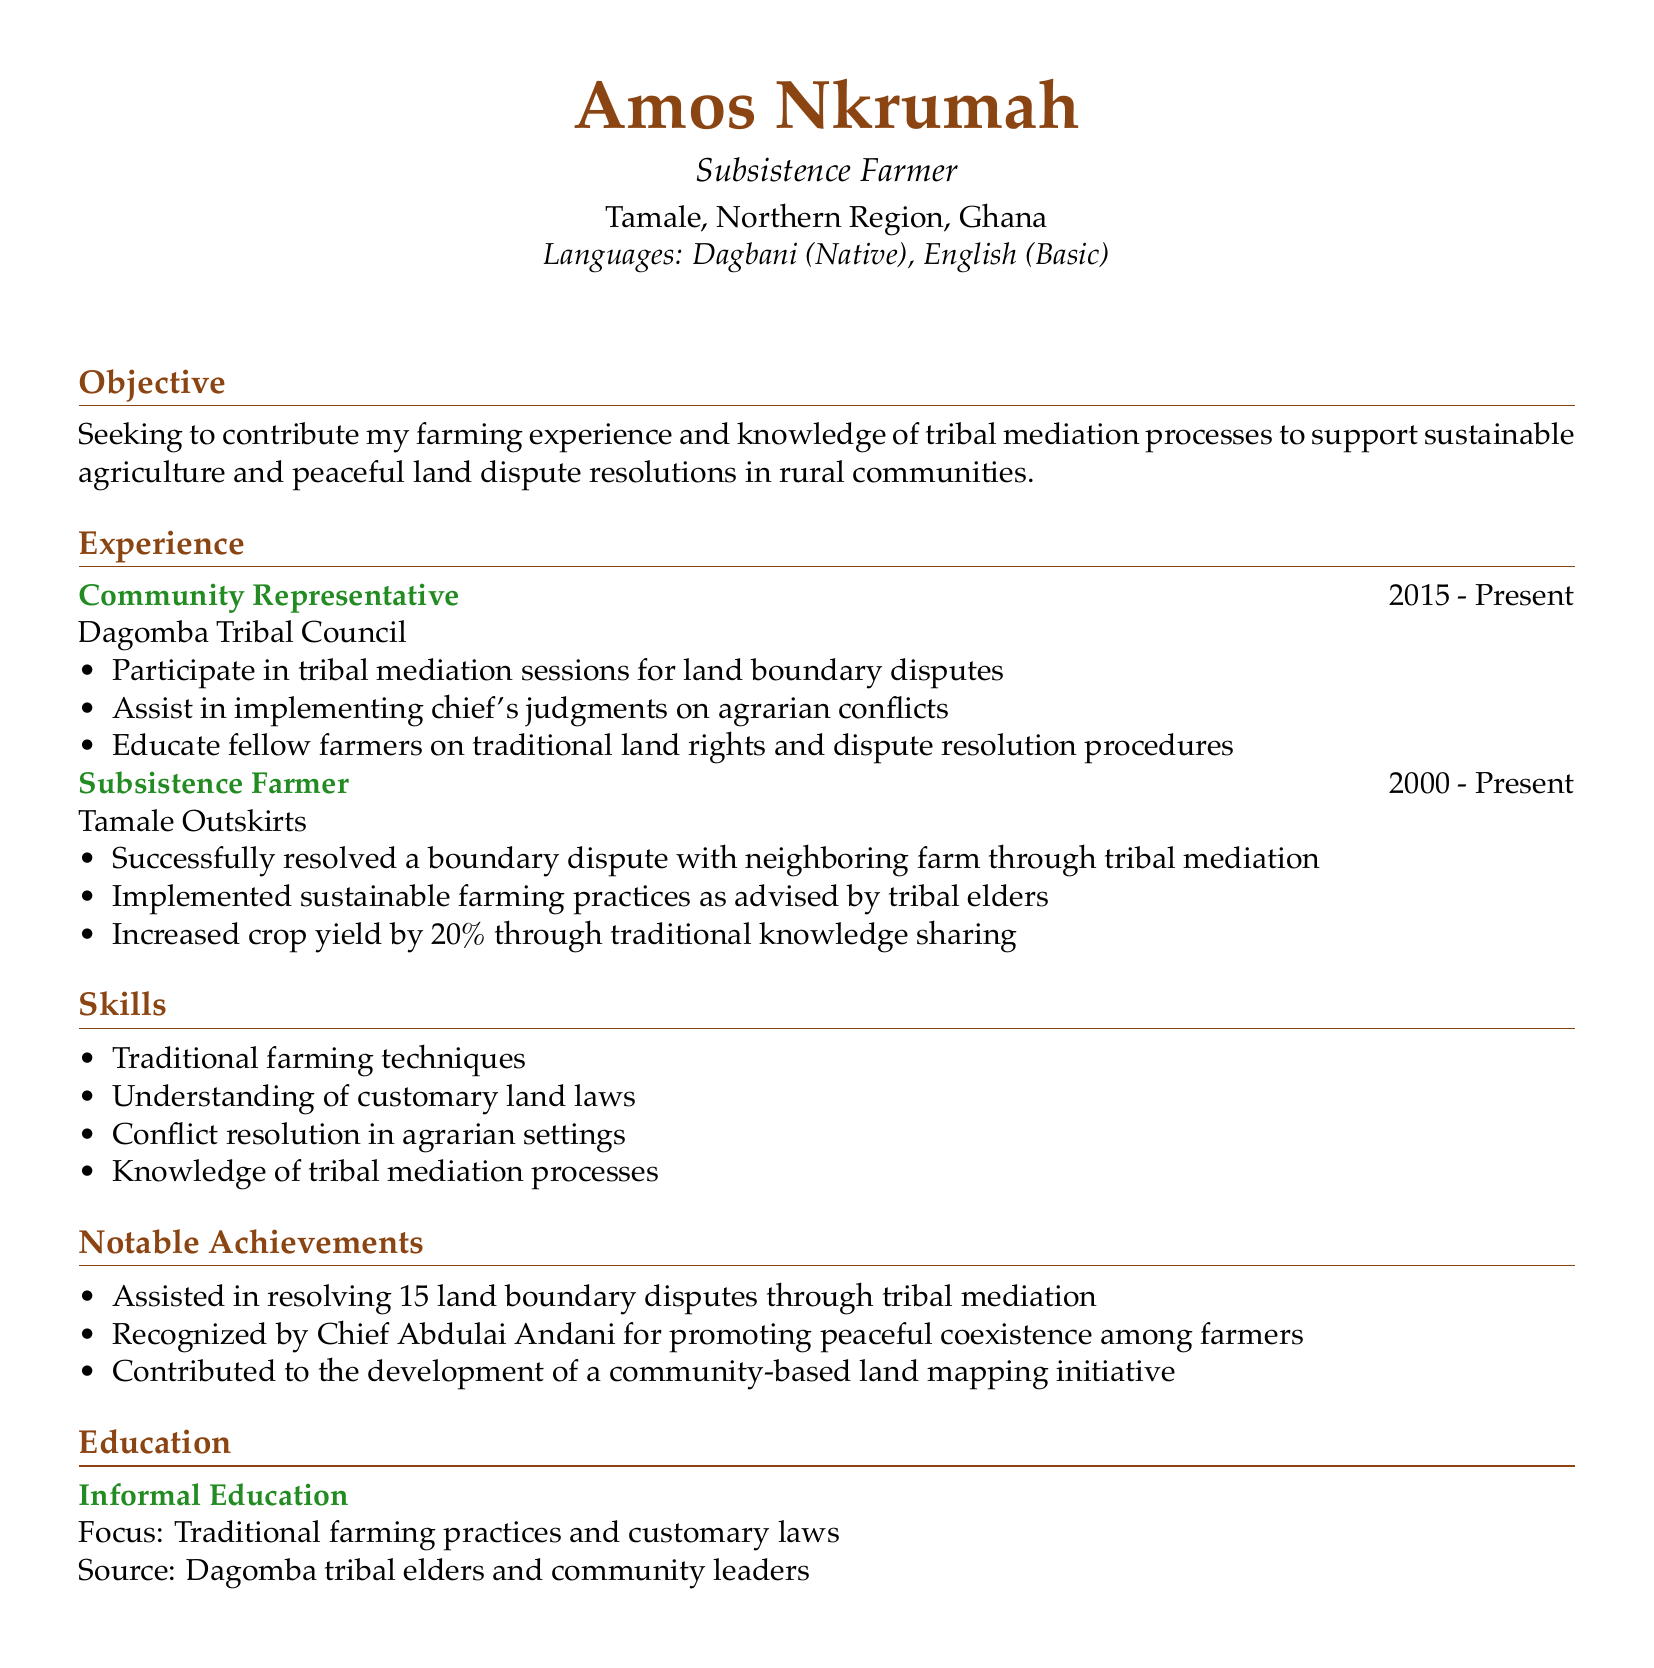What is the name of the individual? The name is provided in the personal info section of the document.
Answer: Amos Nkrumah What is the location of the individual? The location is stated in the personal info section.
Answer: Tamale, Northern Region, Ghana What is the title of the individual's role in the Dagomba Tribal Council? The title is mentioned in the experience section.
Answer: Community Representative How many land boundary disputes has the individual assisted in resolving? This information is provided under notable achievements.
Answer: 15 What percentage increase in crop yield did the individual achieve? The percentage increase is listed in the achievements of the experience section.
Answer: 20% Which traditional language does the individual speak? The languages spoken are listed in the personal info section.
Answer: Dagbani What type of education has the individual received? The level of education is provided in the education section.
Answer: Informal Education Who recognized the individual for promoting peaceful coexistence? The recognition is mentioned in the notable achievements section.
Answer: Chief Abdulai Andani What is the objective of the individual? The objective is stated clearly at the beginning of the document.
Answer: Contribute farming experience and knowledge of tribal mediation processes 